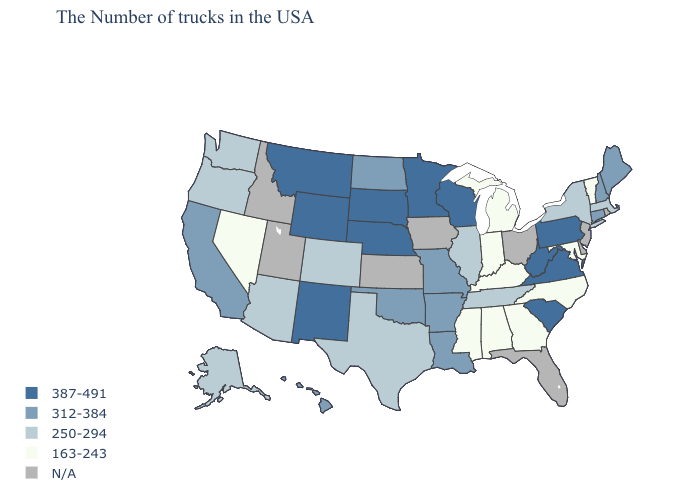Does Missouri have the lowest value in the MidWest?
Short answer required. No. What is the value of Wyoming?
Answer briefly. 387-491. What is the value of Oregon?
Answer briefly. 250-294. Name the states that have a value in the range 163-243?
Give a very brief answer. Vermont, Maryland, North Carolina, Georgia, Michigan, Kentucky, Indiana, Alabama, Mississippi, Nevada. Does Maine have the lowest value in the USA?
Quick response, please. No. What is the value of Maine?
Keep it brief. 312-384. What is the value of New Hampshire?
Keep it brief. 312-384. Does West Virginia have the highest value in the South?
Concise answer only. Yes. What is the lowest value in states that border Missouri?
Write a very short answer. 163-243. Name the states that have a value in the range 387-491?
Be succinct. Pennsylvania, Virginia, South Carolina, West Virginia, Wisconsin, Minnesota, Nebraska, South Dakota, Wyoming, New Mexico, Montana. Is the legend a continuous bar?
Give a very brief answer. No. What is the value of New Mexico?
Be succinct. 387-491. What is the value of New Hampshire?
Short answer required. 312-384. Which states have the highest value in the USA?
Concise answer only. Pennsylvania, Virginia, South Carolina, West Virginia, Wisconsin, Minnesota, Nebraska, South Dakota, Wyoming, New Mexico, Montana. 